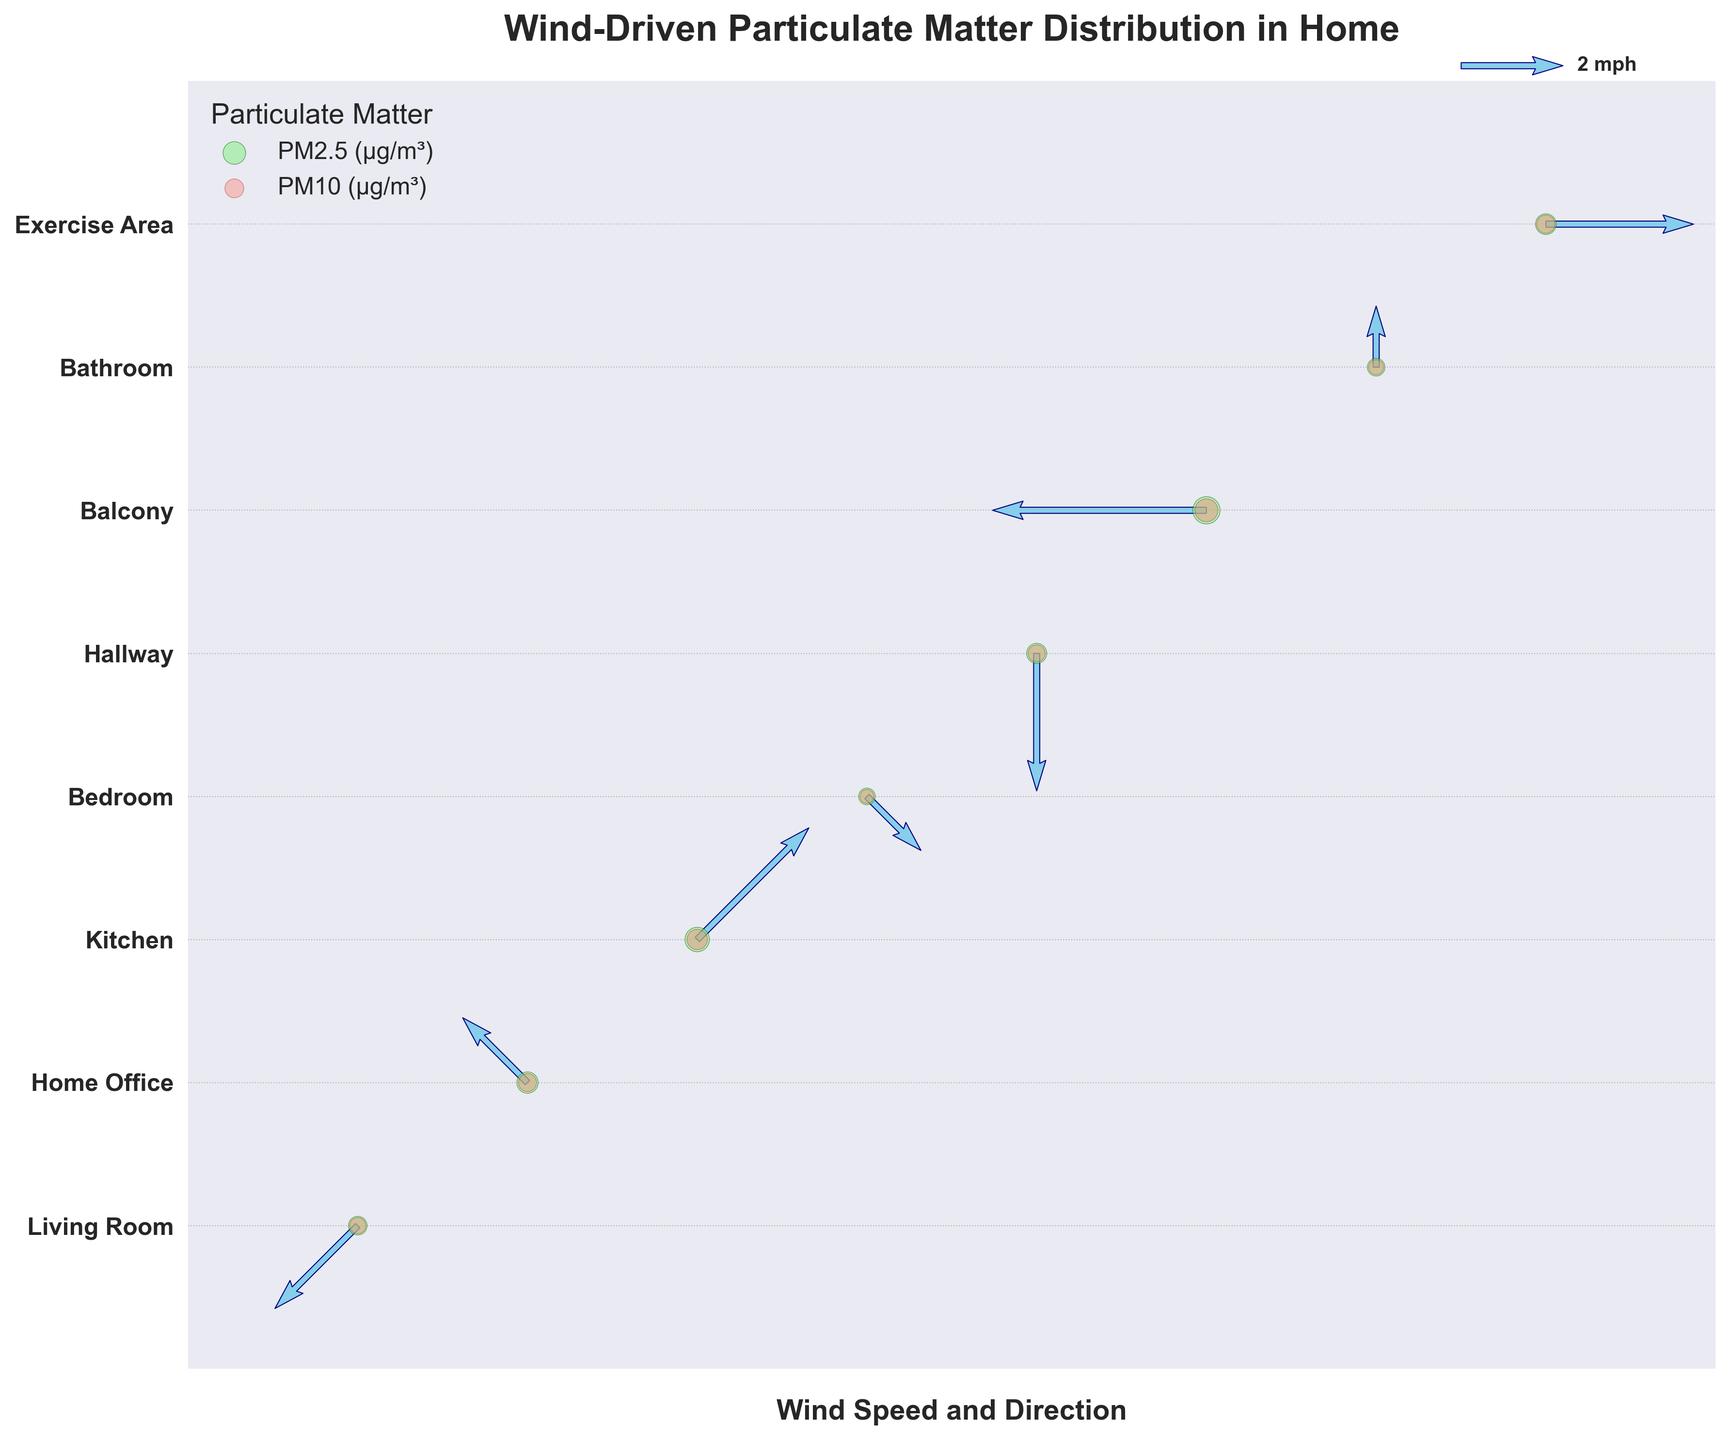What is the title of the plot? The title is placed at the top of the plot in bold text and can be directly observed without any calculations.
Answer: Wind-Driven Particulate Matter Distribution in Home How many different locations are shown in the plot? Each location is represented by a unique y-tick label and a corresponding data point, so counting the y-tick labels will give the number of locations.
Answer: 8 Which location has the highest PM2.5 level? The PM2.5 levels are visually represented by green scatter points, with larger circles indicating higher levels. The largest green circle corresponds to the highest PM2.5 level.
Answer: Balcony What is the wind direction and speed in the Living Room? The wind direction and speed for each location are represented by the arrows. You can look at the arrow's direction and length in the Living Room's row.
Answer: NE, 2.3 mph Which two locations have the closest PM10 levels? Compare the sizes of the red scatter points representing PM10 levels. Identify which two points are closest in size.
Answer: Living Room and Hallway How does the wind speed in the Kitchen compare to that in the Bathroom? The length of the arrows shows wind speed. Compare the arrow lengths in the Kitchen and the Bathroom.
Answer: Higher in the Kitchen What is the range of PM2.5 levels across all locations? Identify the smallest and largest green scatter points representing PM2.5 levels, and use those to determine the range.
Answer: 6.8 to 18.3 μg/m³ Which location experiences a South wind direction, and what is its corresponding PM2.5 level? Look for the arrow pointing upwards, which indicates a South wind, and check the corresponding green scatter point for PM2.5 level.
Answer: Bathroom, 7.6 μg/m³ How does the PM10 level in the Home Office compare to the Exercise Area? Compare the sizes of the red scatter points for both locations to determine which one is larger.
Answer: Higher in Home Office 